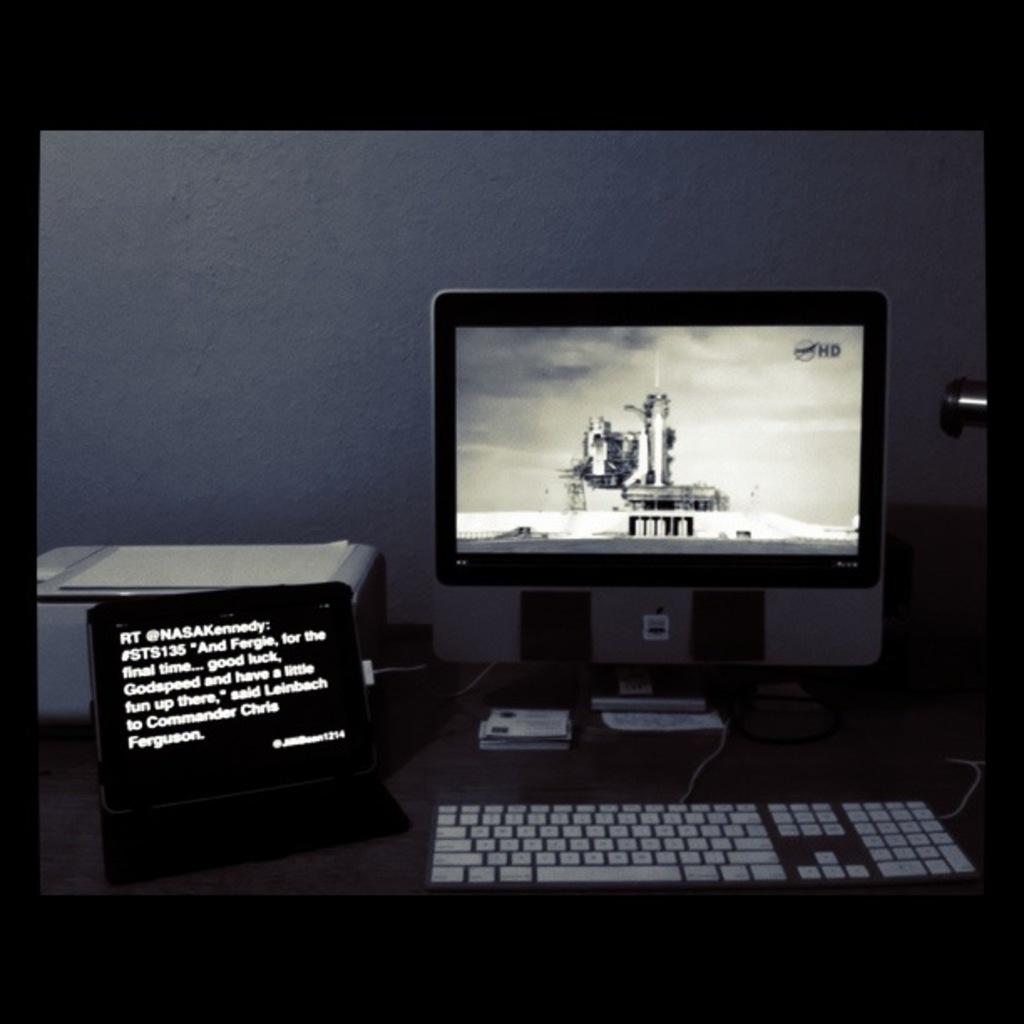Provide a one-sentence caption for the provided image. A computer is on a desk next to a laptop that shows a quote from Leinbach to Commander Chris Ferguson. 